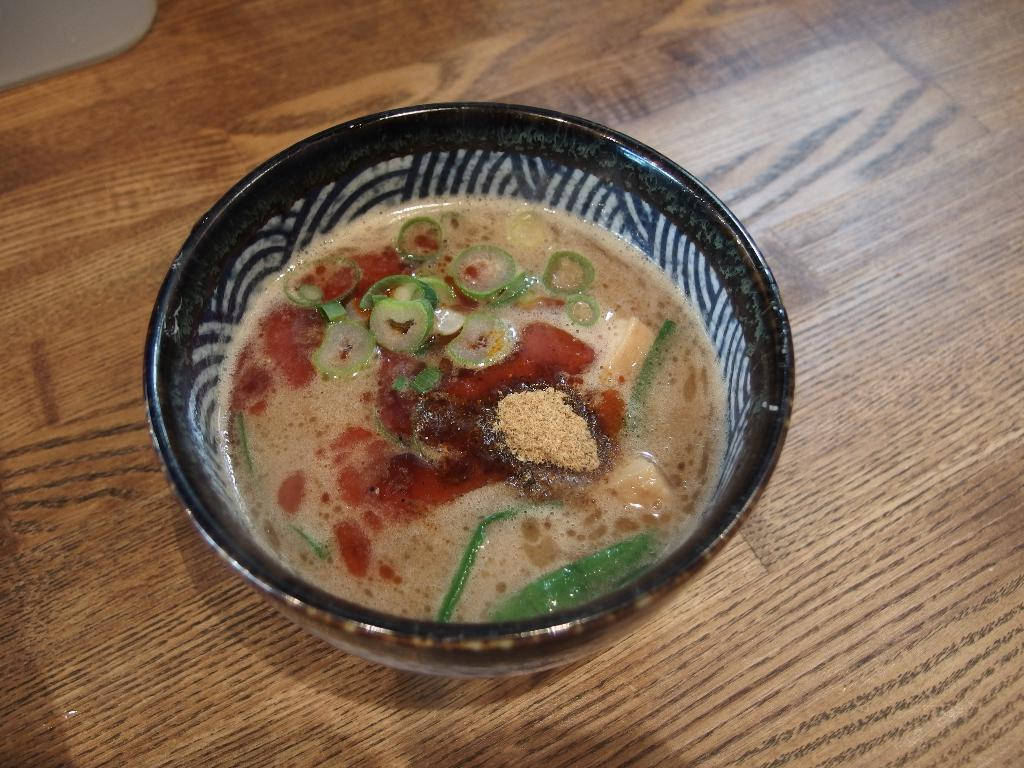What type of table is in the image? There is a wooden table in the image. What is on top of the table? There is a bowl on the table. What is inside the bowl? The bowl contains soup. How many chairs are visible around the table in the image? There is no information about chairs in the image, so we cannot determine the number of chairs. 